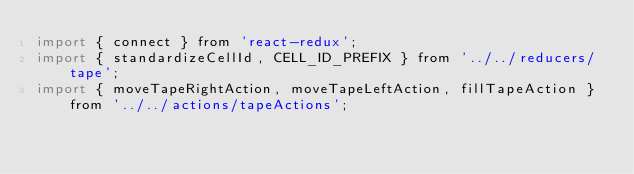Convert code to text. <code><loc_0><loc_0><loc_500><loc_500><_JavaScript_>import { connect } from 'react-redux';
import { standardizeCellId, CELL_ID_PREFIX } from '../../reducers/tape';
import { moveTapeRightAction, moveTapeLeftAction, fillTapeAction } from '../../actions/tapeActions';</code> 